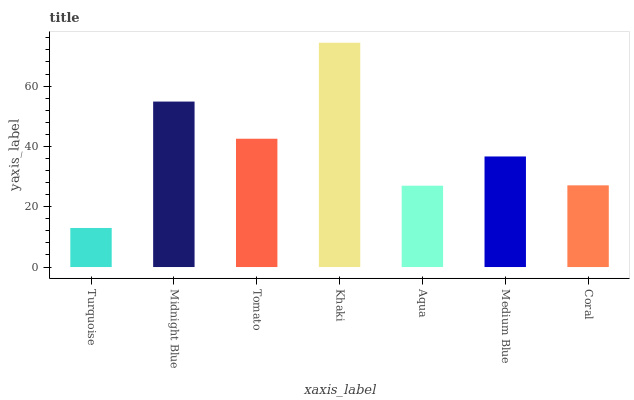Is Turquoise the minimum?
Answer yes or no. Yes. Is Khaki the maximum?
Answer yes or no. Yes. Is Midnight Blue the minimum?
Answer yes or no. No. Is Midnight Blue the maximum?
Answer yes or no. No. Is Midnight Blue greater than Turquoise?
Answer yes or no. Yes. Is Turquoise less than Midnight Blue?
Answer yes or no. Yes. Is Turquoise greater than Midnight Blue?
Answer yes or no. No. Is Midnight Blue less than Turquoise?
Answer yes or no. No. Is Medium Blue the high median?
Answer yes or no. Yes. Is Medium Blue the low median?
Answer yes or no. Yes. Is Aqua the high median?
Answer yes or no. No. Is Coral the low median?
Answer yes or no. No. 